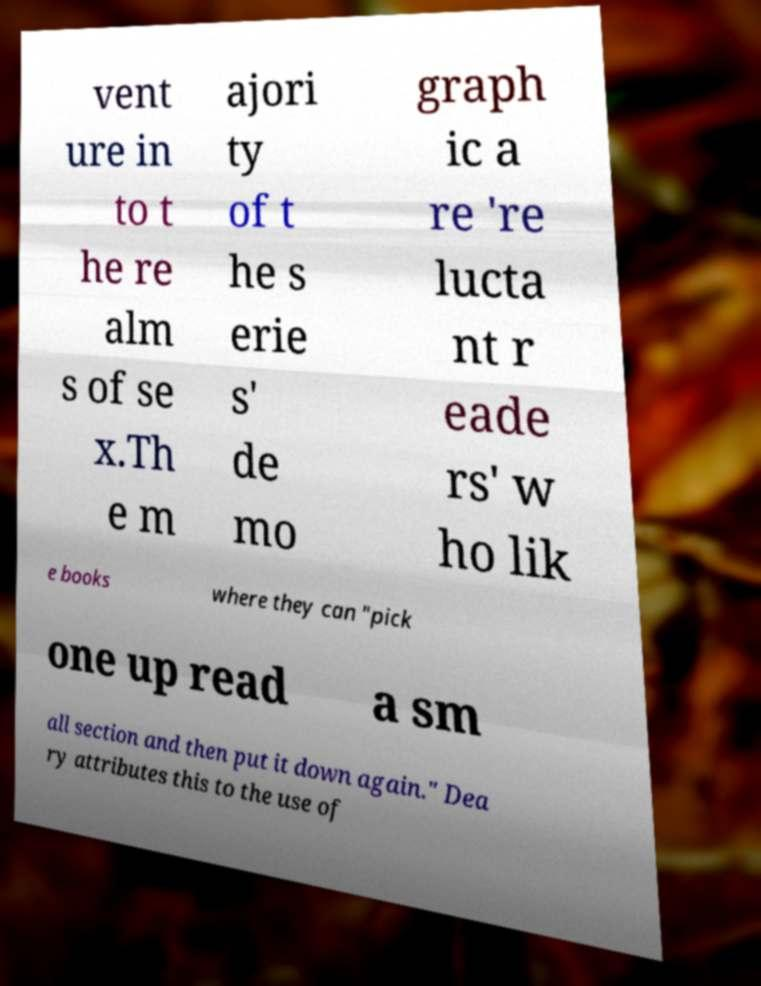What messages or text are displayed in this image? I need them in a readable, typed format. vent ure in to t he re alm s of se x.Th e m ajori ty of t he s erie s' de mo graph ic a re 're lucta nt r eade rs' w ho lik e books where they can "pick one up read a sm all section and then put it down again." Dea ry attributes this to the use of 